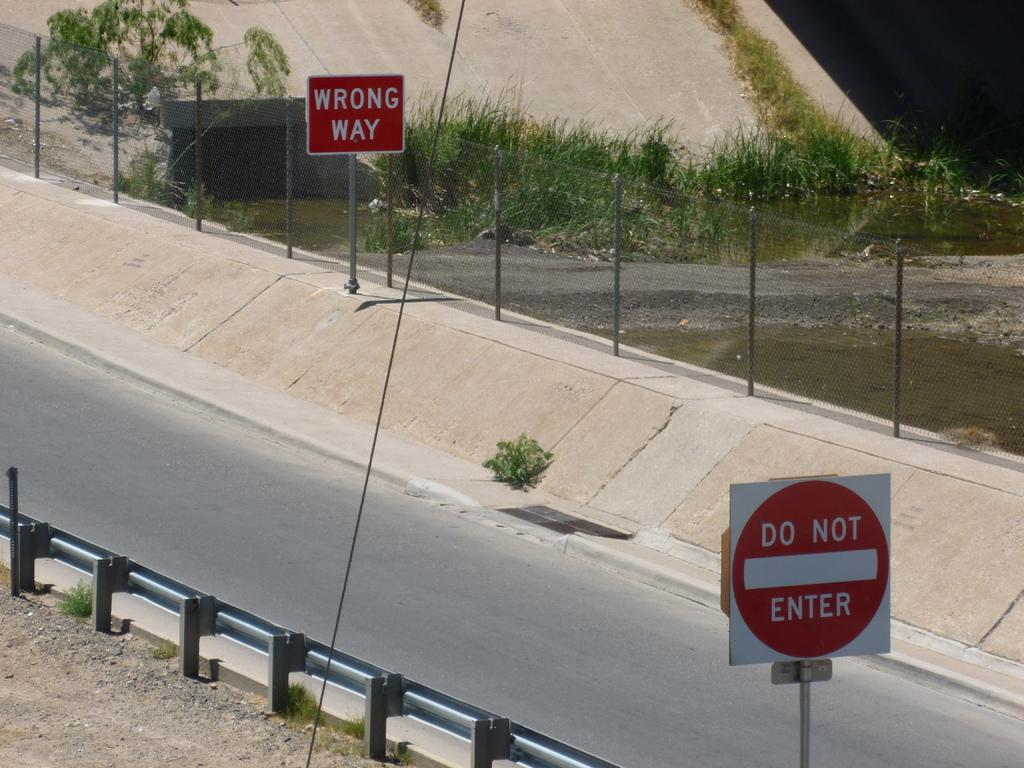<image>
Summarize the visual content of the image. Do not enter and wrong way signs on off ramp of highway 